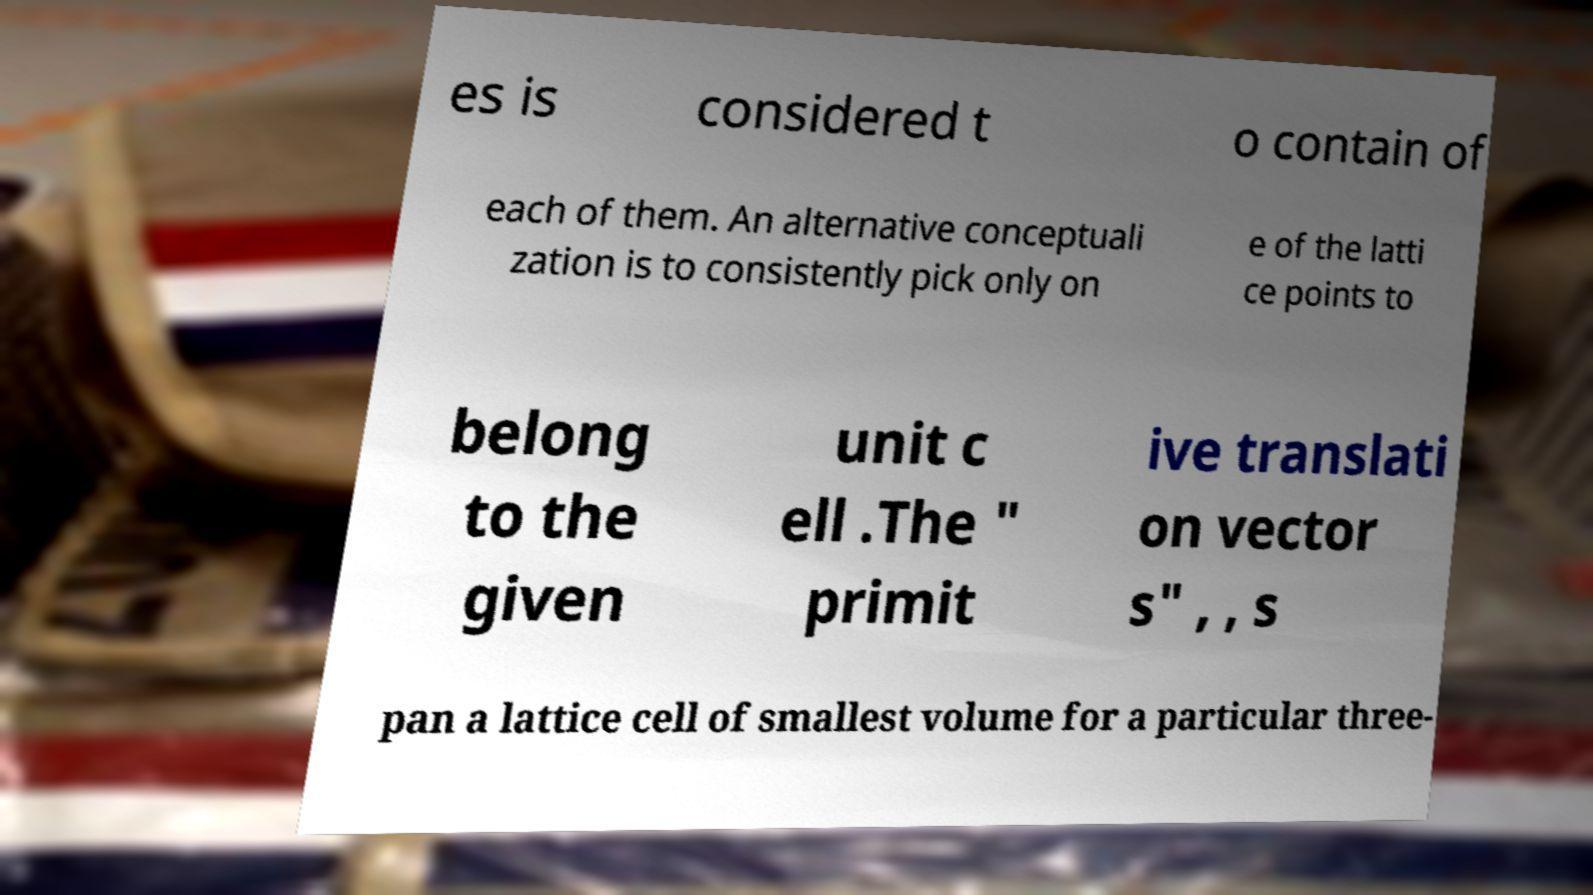Can you accurately transcribe the text from the provided image for me? es is considered t o contain of each of them. An alternative conceptuali zation is to consistently pick only on e of the latti ce points to belong to the given unit c ell .The " primit ive translati on vector s" , , s pan a lattice cell of smallest volume for a particular three- 